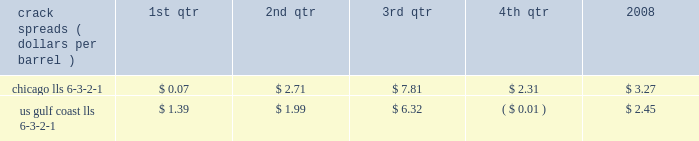Our refining and wholesale marketing gross margin is the difference between the prices of refined products sold and the costs of crude oil and other charge and blendstocks refined , including the costs to transport these inputs to our refineries , the costs of purchased products and manufacturing expenses , including depreciation .
The crack spread is a measure of the difference between market prices for refined products and crude oil , commonly used by the industry as an indicator of the impact of price on the refining margin .
Crack spreads can fluctuate significantly , particularly when prices of refined products do not move in the same relationship as the cost of crude oil .
As a performance benchmark and a comparison with other industry participants , we calculate midwest ( chicago ) and u.s .
Gulf coast crack spreads that we feel most closely track our operations and slate of products .
Posted light louisiana sweet ( 201clls 201d ) prices and a 6-3-2-1 ratio of products ( 6 barrels of crude oil producing 3 barrels of gasoline , 2 barrels of distillate and 1 barrel of residual fuel ) are used for the crack spread calculation .
The table lists calculated average crack spreads by quarter for the midwest ( chicago ) and gulf coast markets in 2008 .
Crack spreads ( dollars per barrel ) 1st qtr 2nd qtr 3rd qtr 4th qtr 2008 .
In addition to the market changes indicated by the crack spreads , our refining and wholesale marketing gross margin is impacted by factors such as the types of crude oil and other charge and blendstocks processed , the selling prices realized for refined products , the impact of commodity derivative instruments used to mitigate price risk and the cost of purchased products for resale .
We process significant amounts of sour crude oil which can enhance our profitability compared to certain of our competitors , as sour crude oil typically can be purchased at a discount to sweet crude oil .
Finally , our refining and wholesale marketing gross margin is impacted by changes in manufacturing costs , which are primarily driven by the level of maintenance activities at the refineries and the price of purchased natural gas used for plant fuel .
Our 2008 refining and wholesale marketing gross margin was the key driver of the 43 percent decrease in rm&t segment income when compared to 2007 .
Our average refining and wholesale marketing gross margin per gallon decreased 37 percent , to 11.66 cents in 2008 from 18.48 cents in 2007 , primarily due to the significant and rapid increases in crude oil prices early in 2008 and lagging wholesale price realizations .
Our retail marketing gross margin for gasoline and distillates , which is the difference between the ultimate price paid by consumers and the cost of refined products , including secondary transportation and consumer excise taxes , also impacts rm&t segment profitability .
While on average demand has been increasing for several years , there are numerous factors including local competition , seasonal demand fluctuations , the available wholesale supply , the level of economic activity in our marketing areas and weather conditions that impact gasoline and distillate demand throughout the year .
In 2008 , demand began to drop due to the combination of significant increases in retail petroleum prices and a broad slowdown in general activity .
The gross margin on merchandise sold at retail outlets has historically been more constant .
The profitability of our pipeline transportation operations is primarily dependent on the volumes shipped through our crude oil and refined products pipelines .
The volume of crude oil that we transport is directly affected by the supply of , and refiner demand for , crude oil in the markets served directly by our crude oil pipelines .
Key factors in this supply and demand balance are the production levels of crude oil by producers , the availability and cost of alternative modes of transportation , and refinery and transportation system maintenance levels .
The volume of refined products that we transport is directly affected by the production levels of , and user demand for , refined products in the markets served by our refined product pipelines .
In most of our markets , demand for gasoline peaks during the summer and declines during the fall and winter months , whereas distillate demand is more ratable throughout the year .
As with crude oil , other transportation alternatives and system maintenance levels influence refined product movements .
Integrated gas our integrated gas strategy is to link stranded natural gas resources with areas where a supply gap is emerging due to declining production and growing demand .
Our integrated gas operations include marketing and transportation of products manufactured from natural gas , such as lng and methanol , primarily in the u.s. , europe and west africa .
Our most significant lng investment is our 60 percent ownership in a production facility in equatorial guinea , which sells lng under a long-term contract at prices tied to henry hub natural gas prices .
In 2008 , its .
What was the difference between the total 2008 crack spreads of chicago and the u.s gulf coast? 
Computations: (3.27 - 2.45)
Answer: 0.82. 